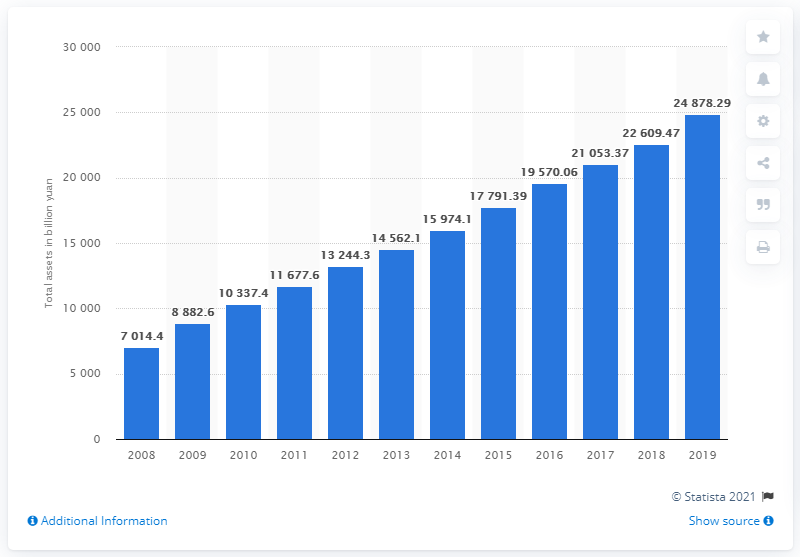Mention a couple of crucial points in this snapshot. In 2019, the total assets of the Agricultural Bank of China were worth 248,782.29. 